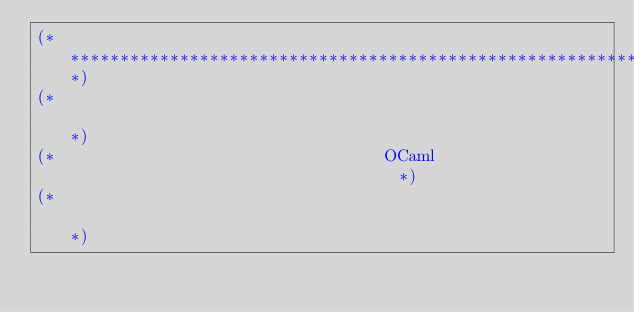<code> <loc_0><loc_0><loc_500><loc_500><_OCaml_>(**************************************************************************)
(*                                                                        *)
(*                                 OCaml                                  *)
(*                                                                        *)</code> 